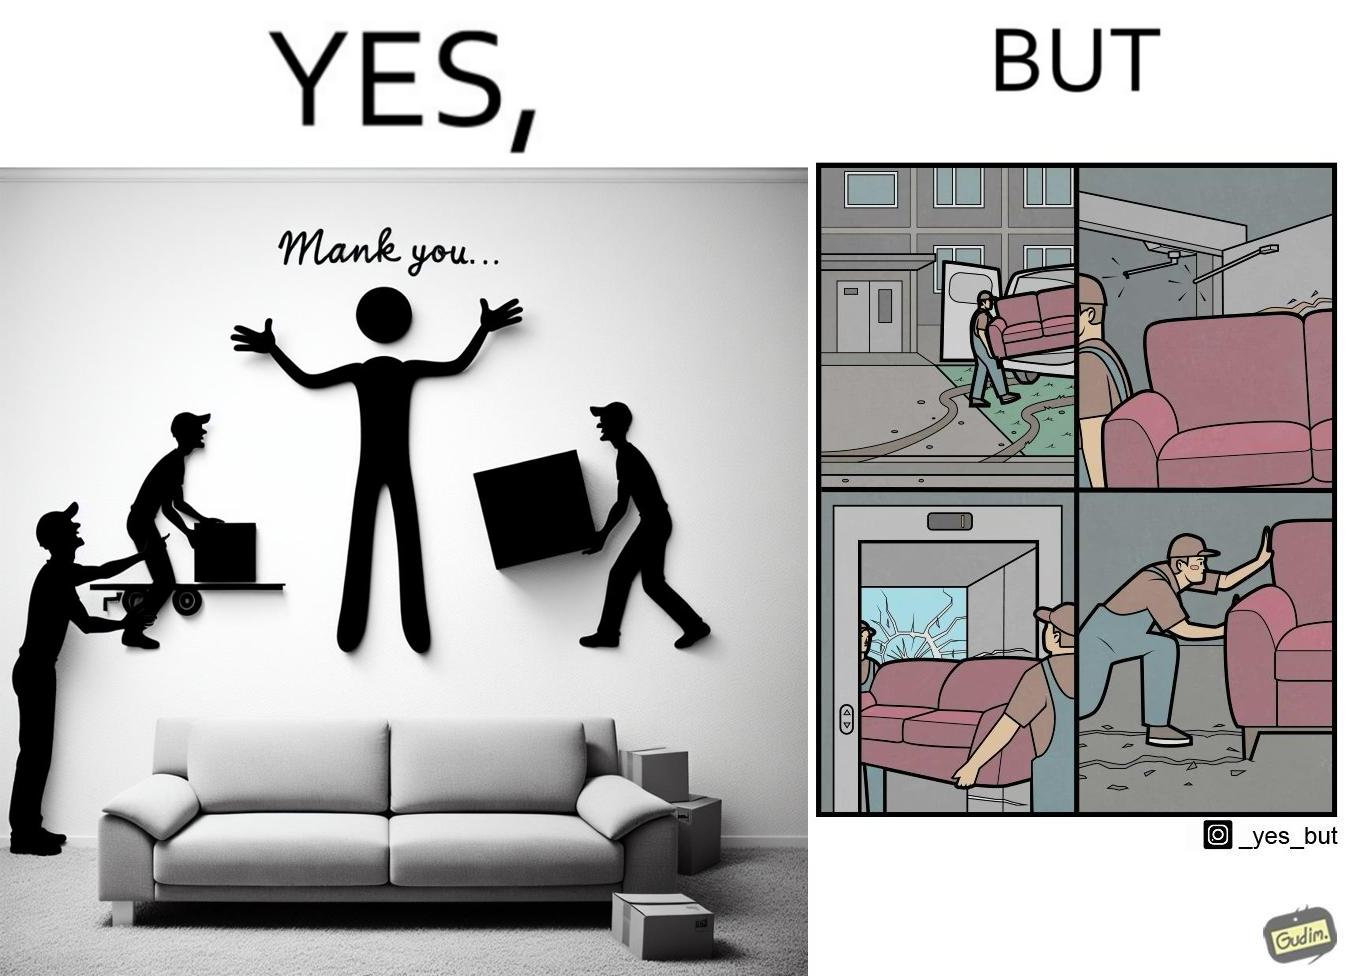What is shown in the left half versus the right half of this image? In the left part of the image: A man happy with movers who have helped move in a sofa In the right part of the image: Images show how movers have damaged a house while moving in furniture 